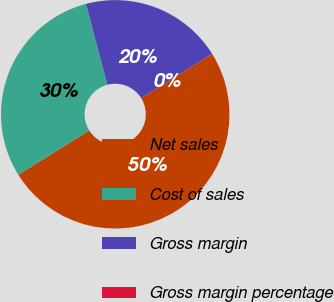Convert chart. <chart><loc_0><loc_0><loc_500><loc_500><pie_chart><fcel>Net sales<fcel>Cost of sales<fcel>Gross margin<fcel>Gross margin percentage<nl><fcel>49.99%<fcel>29.75%<fcel>20.24%<fcel>0.02%<nl></chart> 